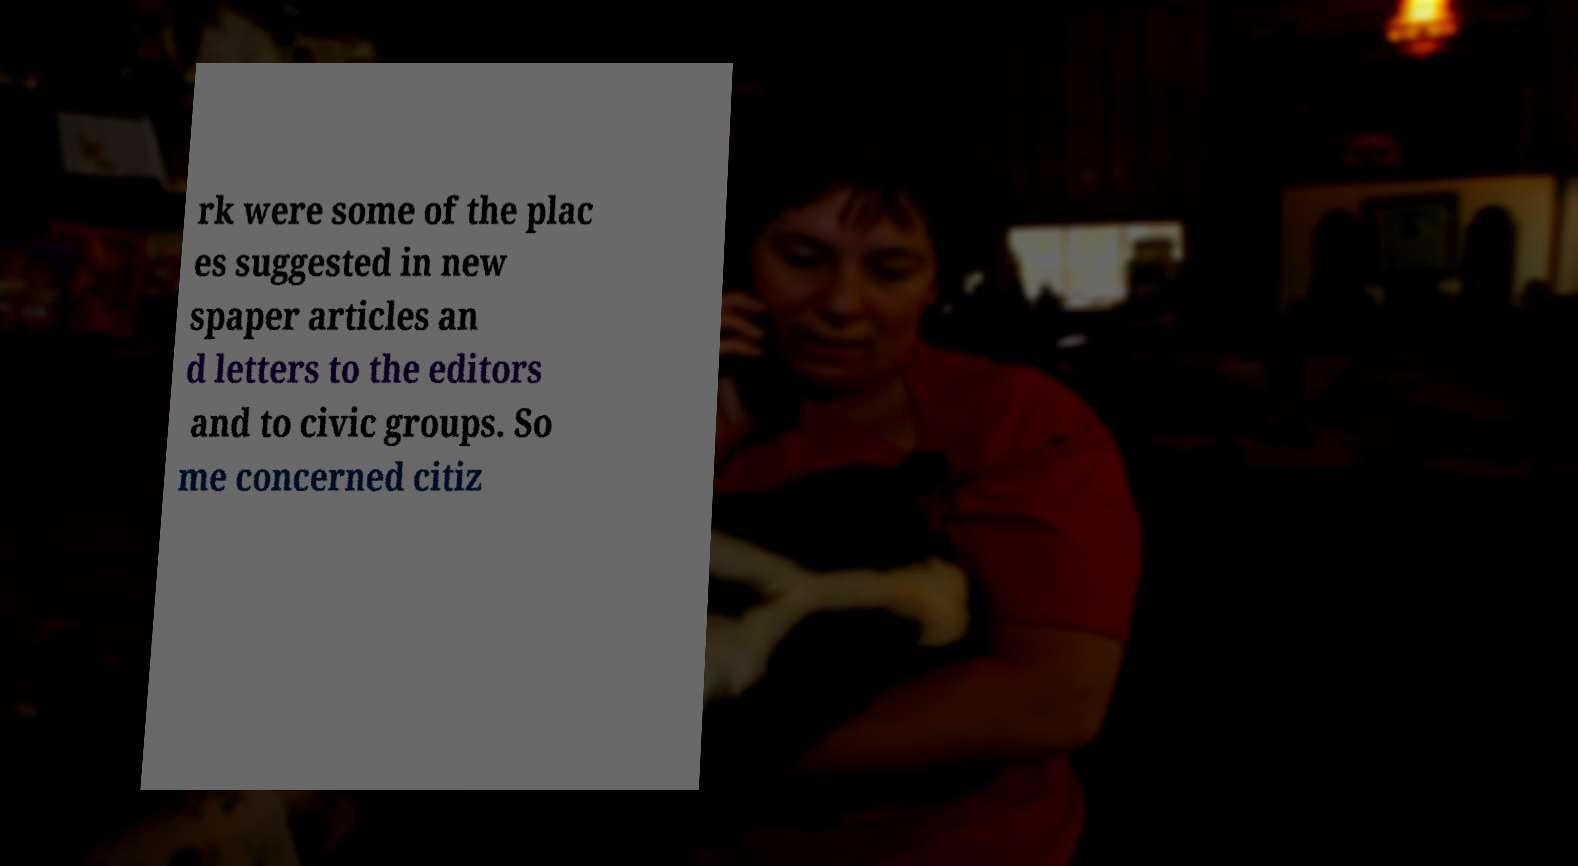For documentation purposes, I need the text within this image transcribed. Could you provide that? rk were some of the plac es suggested in new spaper articles an d letters to the editors and to civic groups. So me concerned citiz 